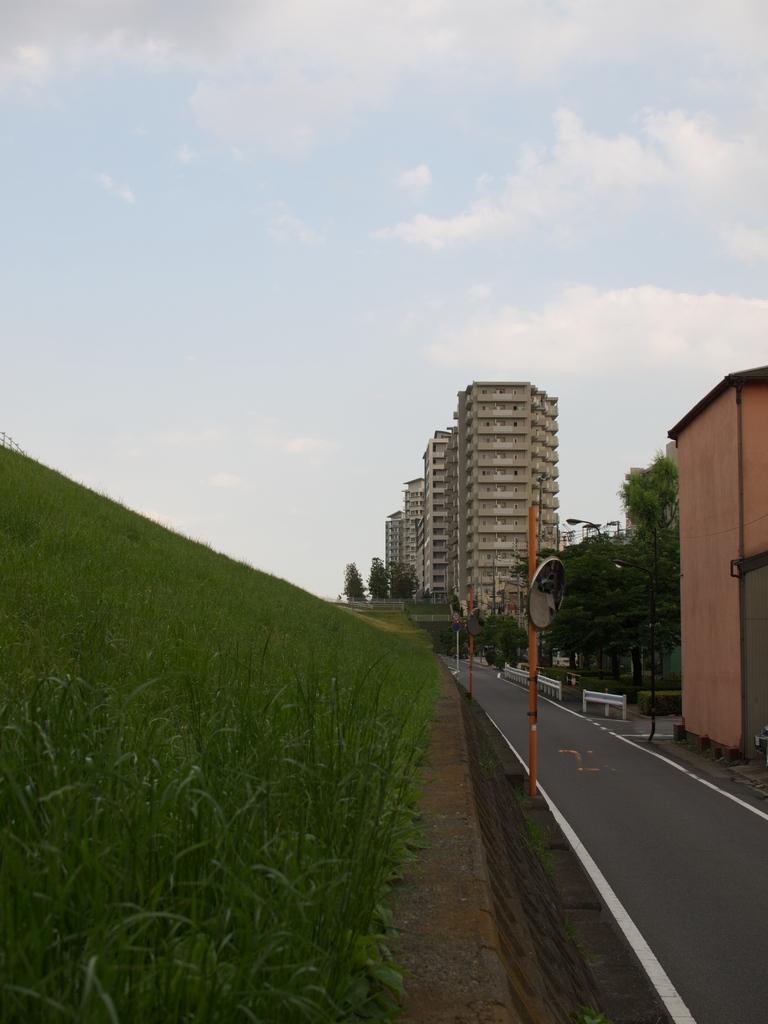How would you summarize this image in a sentence or two? In this image I can see grass, number of poles with mirrors. I can also see few buildings, trees and street lights. In the background I can see cloudy sky. 